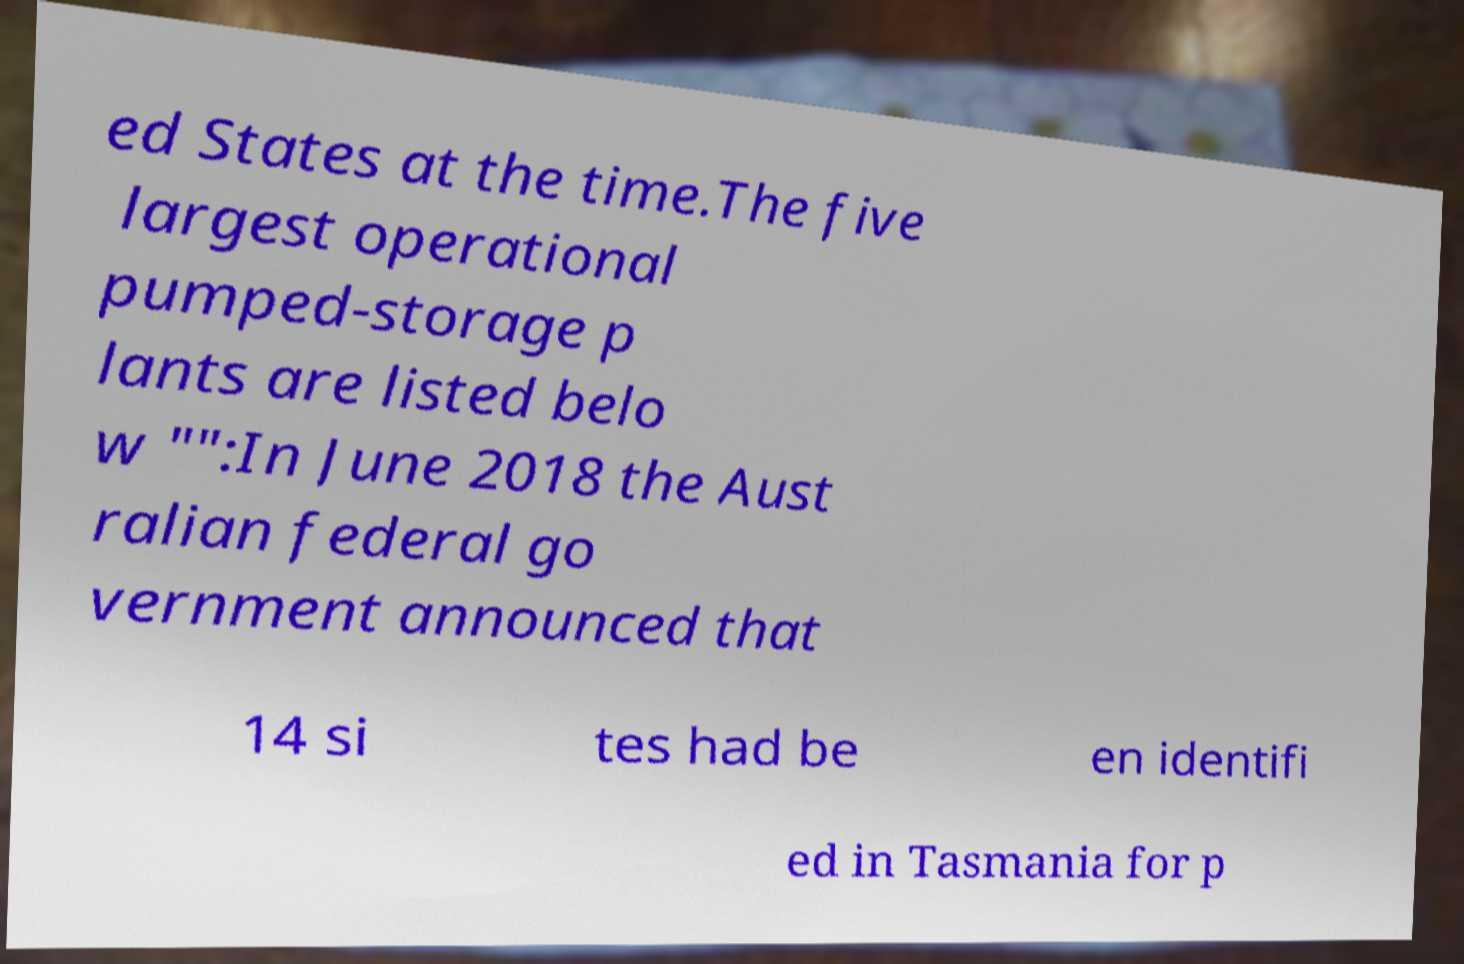Could you extract and type out the text from this image? ed States at the time.The five largest operational pumped-storage p lants are listed belo w "":In June 2018 the Aust ralian federal go vernment announced that 14 si tes had be en identifi ed in Tasmania for p 